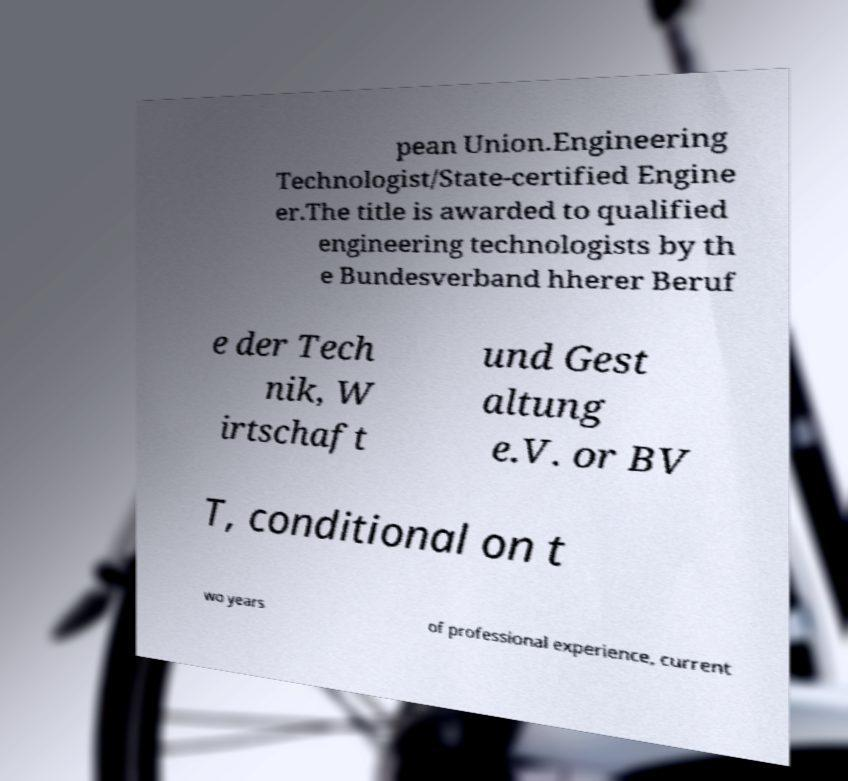Can you accurately transcribe the text from the provided image for me? pean Union.Engineering Technologist/State-certified Engine er.The title is awarded to qualified engineering technologists by th e Bundesverband hherer Beruf e der Tech nik, W irtschaft und Gest altung e.V. or BV T, conditional on t wo years of professional experience, current 